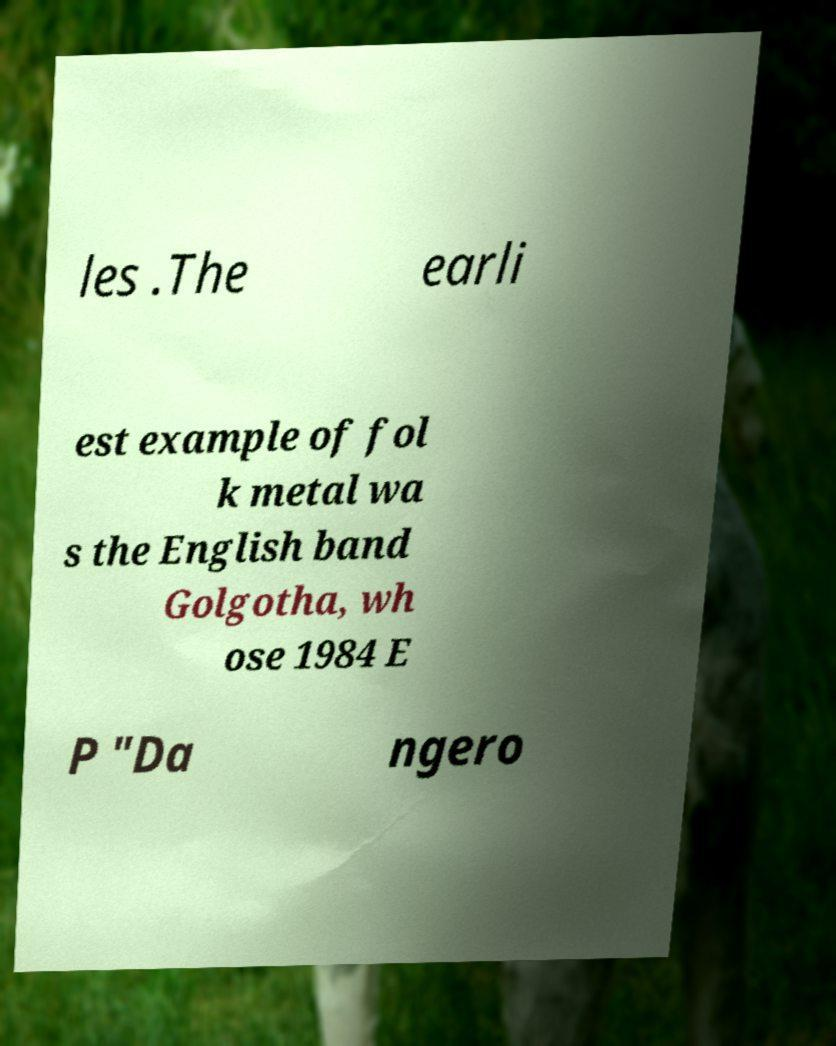I need the written content from this picture converted into text. Can you do that? les .The earli est example of fol k metal wa s the English band Golgotha, wh ose 1984 E P "Da ngero 